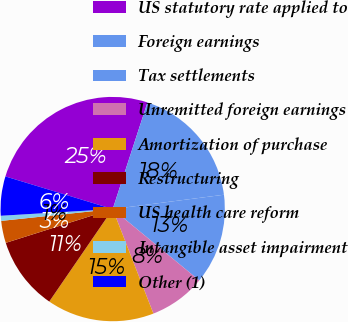Convert chart to OTSL. <chart><loc_0><loc_0><loc_500><loc_500><pie_chart><fcel>US statutory rate applied to<fcel>Foreign earnings<fcel>Tax settlements<fcel>Unremitted foreign earnings<fcel>Amortization of purchase<fcel>Restructuring<fcel>US health care reform<fcel>Intangible asset impairment<fcel>Other (1)<nl><fcel>25.32%<fcel>17.94%<fcel>13.02%<fcel>8.11%<fcel>15.48%<fcel>10.56%<fcel>3.19%<fcel>0.73%<fcel>5.65%<nl></chart> 